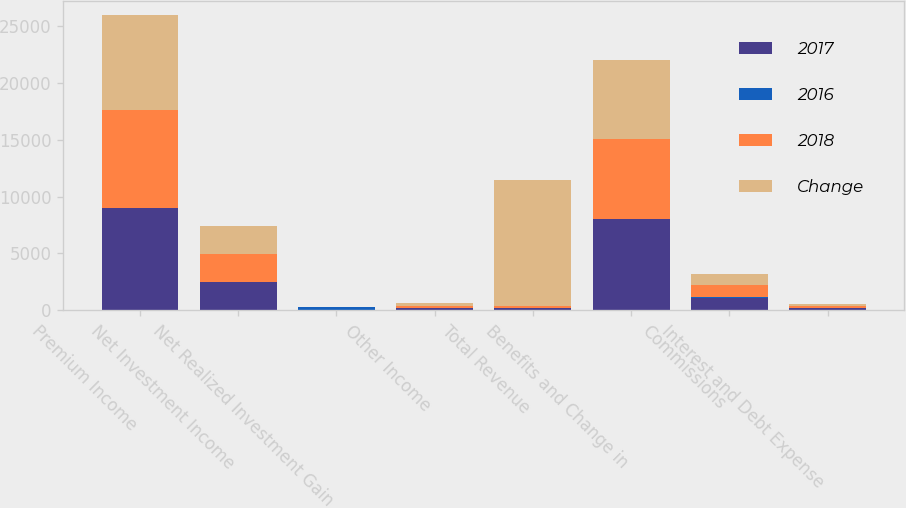Convert chart to OTSL. <chart><loc_0><loc_0><loc_500><loc_500><stacked_bar_chart><ecel><fcel>Premium Income<fcel>Net Investment Income<fcel>Net Realized Investment Gain<fcel>Other Income<fcel>Total Revenue<fcel>Benefits and Change in<fcel>Commissions<fcel>Interest and Debt Expense<nl><fcel>2017<fcel>8986.1<fcel>2453.7<fcel>39.5<fcel>198.2<fcel>198.1<fcel>8020.4<fcel>1108.4<fcel>167.3<nl><fcel>2016<fcel>4.5<fcel>0.1<fcel>198<fcel>0.3<fcel>2.8<fcel>13.7<fcel>4.5<fcel>4.6<nl><fcel>2018<fcel>8597.1<fcel>2451.7<fcel>40.3<fcel>197.7<fcel>198.1<fcel>7055.7<fcel>1060.8<fcel>159.9<nl><fcel>Change<fcel>8357.7<fcel>2459<fcel>24.2<fcel>205.6<fcel>11046.5<fcel>6941.8<fcel>1026.7<fcel>166<nl></chart> 